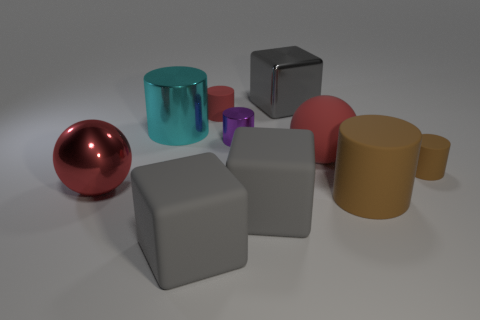Subtract all large rubber cubes. How many cubes are left? 1 Subtract all brown cylinders. How many cylinders are left? 3 Subtract 2 cylinders. How many cylinders are left? 3 Subtract all brown cylinders. How many green spheres are left? 0 Subtract all blocks. How many objects are left? 7 Subtract all yellow balls. Subtract all red blocks. How many balls are left? 2 Subtract all big red metallic spheres. Subtract all gray shiny cubes. How many objects are left? 8 Add 1 small cylinders. How many small cylinders are left? 4 Add 1 big purple metal cubes. How many big purple metal cubes exist? 1 Subtract 0 green cubes. How many objects are left? 10 